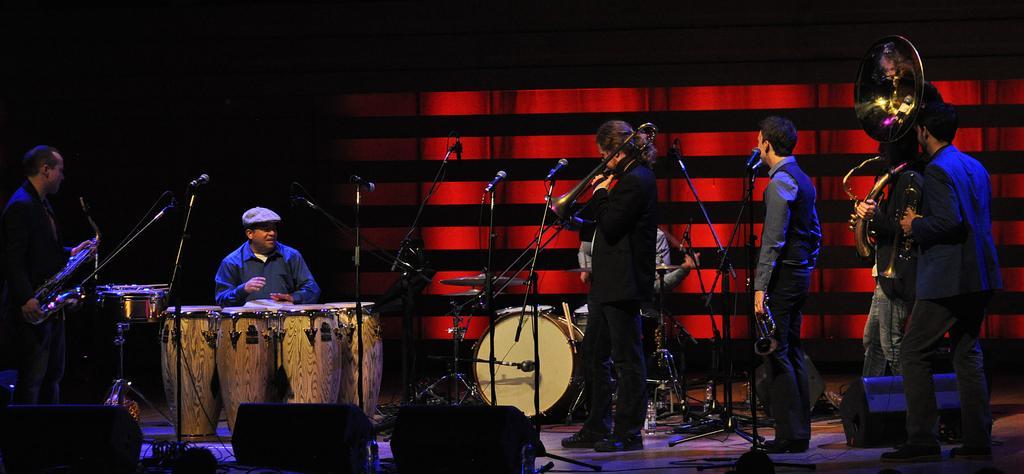How would you summarize this image in a sentence or two? This is the picture of a stage show where some people are standing and the other person is sitting in playing some musical instruments. 